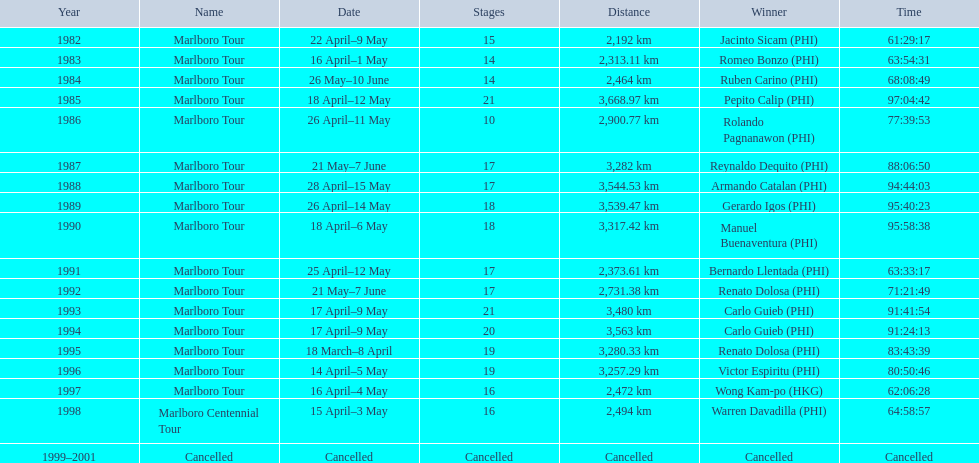What distance did the marlboro tour cover annually? 2,192 km, 2,313.11 km, 2,464 km, 3,668.97 km, 2,900.77 km, 3,282 km, 3,544.53 km, 3,539.47 km, 3,317.42 km, 2,373.61 km, 2,731.38 km, 3,480 km, 3,563 km, 3,280.33 km, 3,257.29 km, 2,472 km, 2,494 km, Cancelled. In which year was the longest distance traveled? 1985. What was the distance covered during that year? 3,668.97 km. 